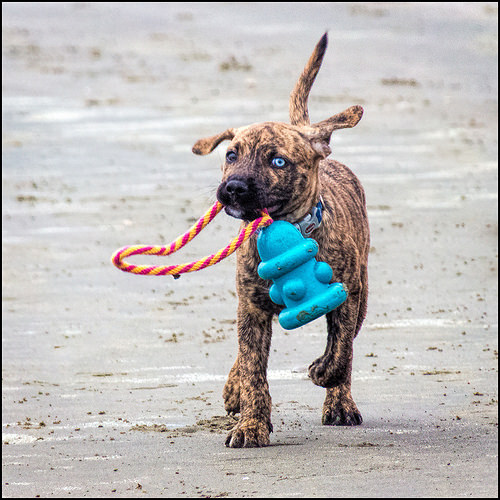<image>
Is the toy behind the dog? No. The toy is not behind the dog. From this viewpoint, the toy appears to be positioned elsewhere in the scene. 